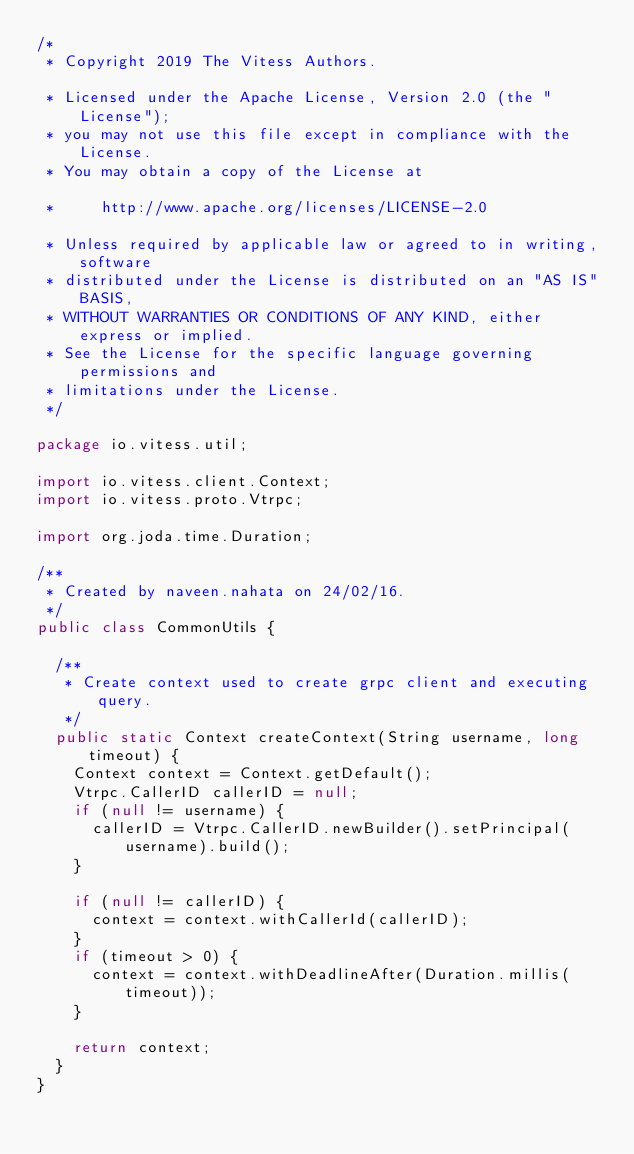<code> <loc_0><loc_0><loc_500><loc_500><_Java_>/*
 * Copyright 2019 The Vitess Authors.

 * Licensed under the Apache License, Version 2.0 (the "License");
 * you may not use this file except in compliance with the License.
 * You may obtain a copy of the License at

 *     http://www.apache.org/licenses/LICENSE-2.0

 * Unless required by applicable law or agreed to in writing, software
 * distributed under the License is distributed on an "AS IS" BASIS,
 * WITHOUT WARRANTIES OR CONDITIONS OF ANY KIND, either express or implied.
 * See the License for the specific language governing permissions and
 * limitations under the License.
 */

package io.vitess.util;

import io.vitess.client.Context;
import io.vitess.proto.Vtrpc;

import org.joda.time.Duration;

/**
 * Created by naveen.nahata on 24/02/16.
 */
public class CommonUtils {

  /**
   * Create context used to create grpc client and executing query.
   */
  public static Context createContext(String username, long timeout) {
    Context context = Context.getDefault();
    Vtrpc.CallerID callerID = null;
    if (null != username) {
      callerID = Vtrpc.CallerID.newBuilder().setPrincipal(username).build();
    }

    if (null != callerID) {
      context = context.withCallerId(callerID);
    }
    if (timeout > 0) {
      context = context.withDeadlineAfter(Duration.millis(timeout));
    }

    return context;
  }
}

</code> 